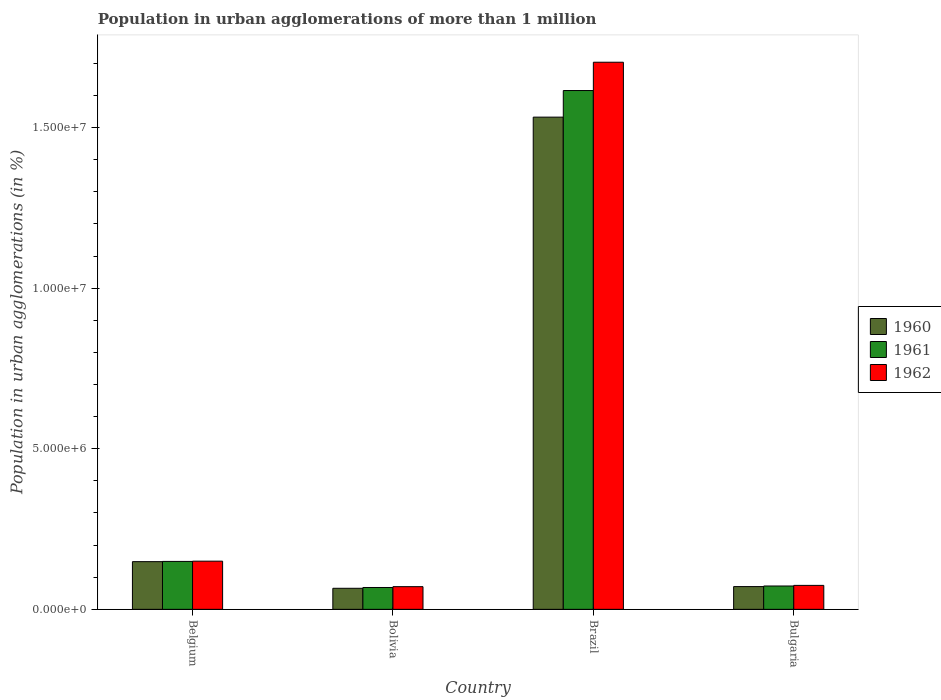How many groups of bars are there?
Your answer should be compact. 4. How many bars are there on the 1st tick from the right?
Provide a short and direct response. 3. In how many cases, is the number of bars for a given country not equal to the number of legend labels?
Offer a terse response. 0. What is the population in urban agglomerations in 1961 in Brazil?
Your answer should be compact. 1.62e+07. Across all countries, what is the maximum population in urban agglomerations in 1960?
Your answer should be very brief. 1.53e+07. Across all countries, what is the minimum population in urban agglomerations in 1960?
Your answer should be very brief. 6.55e+05. What is the total population in urban agglomerations in 1961 in the graph?
Your answer should be very brief. 1.91e+07. What is the difference between the population in urban agglomerations in 1960 in Belgium and that in Brazil?
Your answer should be very brief. -1.38e+07. What is the difference between the population in urban agglomerations in 1962 in Belgium and the population in urban agglomerations in 1961 in Bolivia?
Make the answer very short. 8.19e+05. What is the average population in urban agglomerations in 1962 per country?
Provide a succinct answer. 5.00e+06. What is the difference between the population in urban agglomerations of/in 1962 and population in urban agglomerations of/in 1961 in Brazil?
Give a very brief answer. 8.81e+05. In how many countries, is the population in urban agglomerations in 1960 greater than 1000000 %?
Provide a short and direct response. 2. What is the ratio of the population in urban agglomerations in 1961 in Belgium to that in Bolivia?
Give a very brief answer. 2.19. What is the difference between the highest and the second highest population in urban agglomerations in 1960?
Your answer should be compact. 7.77e+05. What is the difference between the highest and the lowest population in urban agglomerations in 1961?
Offer a terse response. 1.55e+07. In how many countries, is the population in urban agglomerations in 1962 greater than the average population in urban agglomerations in 1962 taken over all countries?
Your answer should be very brief. 1. Is the sum of the population in urban agglomerations in 1962 in Belgium and Brazil greater than the maximum population in urban agglomerations in 1960 across all countries?
Make the answer very short. Yes. What does the 3rd bar from the left in Brazil represents?
Keep it short and to the point. 1962. Is it the case that in every country, the sum of the population in urban agglomerations in 1960 and population in urban agglomerations in 1962 is greater than the population in urban agglomerations in 1961?
Offer a very short reply. Yes. Are all the bars in the graph horizontal?
Your response must be concise. No. Does the graph contain any zero values?
Offer a terse response. No. Where does the legend appear in the graph?
Your response must be concise. Center right. How many legend labels are there?
Your answer should be very brief. 3. How are the legend labels stacked?
Make the answer very short. Vertical. What is the title of the graph?
Your response must be concise. Population in urban agglomerations of more than 1 million. What is the label or title of the X-axis?
Provide a succinct answer. Country. What is the label or title of the Y-axis?
Make the answer very short. Population in urban agglomerations (in %). What is the Population in urban agglomerations (in %) of 1960 in Belgium?
Offer a very short reply. 1.48e+06. What is the Population in urban agglomerations (in %) of 1961 in Belgium?
Offer a very short reply. 1.49e+06. What is the Population in urban agglomerations (in %) of 1962 in Belgium?
Offer a terse response. 1.50e+06. What is the Population in urban agglomerations (in %) of 1960 in Bolivia?
Provide a succinct answer. 6.55e+05. What is the Population in urban agglomerations (in %) in 1961 in Bolivia?
Offer a very short reply. 6.80e+05. What is the Population in urban agglomerations (in %) in 1962 in Bolivia?
Provide a short and direct response. 7.06e+05. What is the Population in urban agglomerations (in %) of 1960 in Brazil?
Your answer should be very brief. 1.53e+07. What is the Population in urban agglomerations (in %) of 1961 in Brazil?
Provide a short and direct response. 1.62e+07. What is the Population in urban agglomerations (in %) of 1962 in Brazil?
Offer a very short reply. 1.70e+07. What is the Population in urban agglomerations (in %) in 1960 in Bulgaria?
Make the answer very short. 7.08e+05. What is the Population in urban agglomerations (in %) in 1961 in Bulgaria?
Offer a terse response. 7.27e+05. What is the Population in urban agglomerations (in %) of 1962 in Bulgaria?
Your answer should be compact. 7.46e+05. Across all countries, what is the maximum Population in urban agglomerations (in %) in 1960?
Your response must be concise. 1.53e+07. Across all countries, what is the maximum Population in urban agglomerations (in %) of 1961?
Offer a terse response. 1.62e+07. Across all countries, what is the maximum Population in urban agglomerations (in %) in 1962?
Provide a succinct answer. 1.70e+07. Across all countries, what is the minimum Population in urban agglomerations (in %) of 1960?
Provide a succinct answer. 6.55e+05. Across all countries, what is the minimum Population in urban agglomerations (in %) of 1961?
Your answer should be compact. 6.80e+05. Across all countries, what is the minimum Population in urban agglomerations (in %) of 1962?
Offer a terse response. 7.06e+05. What is the total Population in urban agglomerations (in %) in 1960 in the graph?
Your response must be concise. 1.82e+07. What is the total Population in urban agglomerations (in %) in 1961 in the graph?
Make the answer very short. 1.91e+07. What is the total Population in urban agglomerations (in %) in 1962 in the graph?
Make the answer very short. 2.00e+07. What is the difference between the Population in urban agglomerations (in %) of 1960 in Belgium and that in Bolivia?
Make the answer very short. 8.29e+05. What is the difference between the Population in urban agglomerations (in %) in 1961 in Belgium and that in Bolivia?
Make the answer very short. 8.12e+05. What is the difference between the Population in urban agglomerations (in %) of 1962 in Belgium and that in Bolivia?
Offer a very short reply. 7.94e+05. What is the difference between the Population in urban agglomerations (in %) in 1960 in Belgium and that in Brazil?
Provide a succinct answer. -1.38e+07. What is the difference between the Population in urban agglomerations (in %) of 1961 in Belgium and that in Brazil?
Offer a very short reply. -1.47e+07. What is the difference between the Population in urban agglomerations (in %) of 1962 in Belgium and that in Brazil?
Your response must be concise. -1.55e+07. What is the difference between the Population in urban agglomerations (in %) of 1960 in Belgium and that in Bulgaria?
Your answer should be compact. 7.77e+05. What is the difference between the Population in urban agglomerations (in %) in 1961 in Belgium and that in Bulgaria?
Provide a succinct answer. 7.65e+05. What is the difference between the Population in urban agglomerations (in %) of 1962 in Belgium and that in Bulgaria?
Offer a terse response. 7.54e+05. What is the difference between the Population in urban agglomerations (in %) in 1960 in Bolivia and that in Brazil?
Ensure brevity in your answer.  -1.47e+07. What is the difference between the Population in urban agglomerations (in %) of 1961 in Bolivia and that in Brazil?
Your answer should be very brief. -1.55e+07. What is the difference between the Population in urban agglomerations (in %) in 1962 in Bolivia and that in Brazil?
Ensure brevity in your answer.  -1.63e+07. What is the difference between the Population in urban agglomerations (in %) in 1960 in Bolivia and that in Bulgaria?
Make the answer very short. -5.27e+04. What is the difference between the Population in urban agglomerations (in %) of 1961 in Bolivia and that in Bulgaria?
Offer a very short reply. -4.64e+04. What is the difference between the Population in urban agglomerations (in %) in 1962 in Bolivia and that in Bulgaria?
Offer a terse response. -3.95e+04. What is the difference between the Population in urban agglomerations (in %) in 1960 in Brazil and that in Bulgaria?
Keep it short and to the point. 1.46e+07. What is the difference between the Population in urban agglomerations (in %) in 1961 in Brazil and that in Bulgaria?
Give a very brief answer. 1.54e+07. What is the difference between the Population in urban agglomerations (in %) of 1962 in Brazil and that in Bulgaria?
Provide a short and direct response. 1.63e+07. What is the difference between the Population in urban agglomerations (in %) in 1960 in Belgium and the Population in urban agglomerations (in %) in 1961 in Bolivia?
Ensure brevity in your answer.  8.05e+05. What is the difference between the Population in urban agglomerations (in %) of 1960 in Belgium and the Population in urban agglomerations (in %) of 1962 in Bolivia?
Offer a terse response. 7.79e+05. What is the difference between the Population in urban agglomerations (in %) in 1961 in Belgium and the Population in urban agglomerations (in %) in 1962 in Bolivia?
Your answer should be very brief. 7.86e+05. What is the difference between the Population in urban agglomerations (in %) of 1960 in Belgium and the Population in urban agglomerations (in %) of 1961 in Brazil?
Provide a succinct answer. -1.47e+07. What is the difference between the Population in urban agglomerations (in %) of 1960 in Belgium and the Population in urban agglomerations (in %) of 1962 in Brazil?
Your answer should be very brief. -1.55e+07. What is the difference between the Population in urban agglomerations (in %) of 1961 in Belgium and the Population in urban agglomerations (in %) of 1962 in Brazil?
Keep it short and to the point. -1.55e+07. What is the difference between the Population in urban agglomerations (in %) of 1960 in Belgium and the Population in urban agglomerations (in %) of 1961 in Bulgaria?
Your response must be concise. 7.58e+05. What is the difference between the Population in urban agglomerations (in %) in 1960 in Belgium and the Population in urban agglomerations (in %) in 1962 in Bulgaria?
Offer a terse response. 7.39e+05. What is the difference between the Population in urban agglomerations (in %) of 1961 in Belgium and the Population in urban agglomerations (in %) of 1962 in Bulgaria?
Make the answer very short. 7.46e+05. What is the difference between the Population in urban agglomerations (in %) in 1960 in Bolivia and the Population in urban agglomerations (in %) in 1961 in Brazil?
Your response must be concise. -1.55e+07. What is the difference between the Population in urban agglomerations (in %) in 1960 in Bolivia and the Population in urban agglomerations (in %) in 1962 in Brazil?
Keep it short and to the point. -1.64e+07. What is the difference between the Population in urban agglomerations (in %) of 1961 in Bolivia and the Population in urban agglomerations (in %) of 1962 in Brazil?
Offer a very short reply. -1.64e+07. What is the difference between the Population in urban agglomerations (in %) of 1960 in Bolivia and the Population in urban agglomerations (in %) of 1961 in Bulgaria?
Offer a terse response. -7.11e+04. What is the difference between the Population in urban agglomerations (in %) of 1960 in Bolivia and the Population in urban agglomerations (in %) of 1962 in Bulgaria?
Offer a terse response. -9.02e+04. What is the difference between the Population in urban agglomerations (in %) in 1961 in Bolivia and the Population in urban agglomerations (in %) in 1962 in Bulgaria?
Provide a short and direct response. -6.54e+04. What is the difference between the Population in urban agglomerations (in %) of 1960 in Brazil and the Population in urban agglomerations (in %) of 1961 in Bulgaria?
Offer a very short reply. 1.46e+07. What is the difference between the Population in urban agglomerations (in %) of 1960 in Brazil and the Population in urban agglomerations (in %) of 1962 in Bulgaria?
Provide a succinct answer. 1.46e+07. What is the difference between the Population in urban agglomerations (in %) in 1961 in Brazil and the Population in urban agglomerations (in %) in 1962 in Bulgaria?
Ensure brevity in your answer.  1.54e+07. What is the average Population in urban agglomerations (in %) of 1960 per country?
Give a very brief answer. 4.54e+06. What is the average Population in urban agglomerations (in %) of 1961 per country?
Offer a very short reply. 4.76e+06. What is the average Population in urban agglomerations (in %) in 1962 per country?
Your answer should be compact. 5.00e+06. What is the difference between the Population in urban agglomerations (in %) in 1960 and Population in urban agglomerations (in %) in 1961 in Belgium?
Offer a terse response. -7177. What is the difference between the Population in urban agglomerations (in %) of 1960 and Population in urban agglomerations (in %) of 1962 in Belgium?
Ensure brevity in your answer.  -1.49e+04. What is the difference between the Population in urban agglomerations (in %) in 1961 and Population in urban agglomerations (in %) in 1962 in Belgium?
Give a very brief answer. -7758. What is the difference between the Population in urban agglomerations (in %) of 1960 and Population in urban agglomerations (in %) of 1961 in Bolivia?
Keep it short and to the point. -2.48e+04. What is the difference between the Population in urban agglomerations (in %) of 1960 and Population in urban agglomerations (in %) of 1962 in Bolivia?
Offer a terse response. -5.06e+04. What is the difference between the Population in urban agglomerations (in %) in 1961 and Population in urban agglomerations (in %) in 1962 in Bolivia?
Your answer should be very brief. -2.58e+04. What is the difference between the Population in urban agglomerations (in %) of 1960 and Population in urban agglomerations (in %) of 1961 in Brazil?
Provide a succinct answer. -8.28e+05. What is the difference between the Population in urban agglomerations (in %) in 1960 and Population in urban agglomerations (in %) in 1962 in Brazil?
Your answer should be very brief. -1.71e+06. What is the difference between the Population in urban agglomerations (in %) of 1961 and Population in urban agglomerations (in %) of 1962 in Brazil?
Provide a succinct answer. -8.81e+05. What is the difference between the Population in urban agglomerations (in %) in 1960 and Population in urban agglomerations (in %) in 1961 in Bulgaria?
Ensure brevity in your answer.  -1.85e+04. What is the difference between the Population in urban agglomerations (in %) of 1960 and Population in urban agglomerations (in %) of 1962 in Bulgaria?
Offer a terse response. -3.75e+04. What is the difference between the Population in urban agglomerations (in %) in 1961 and Population in urban agglomerations (in %) in 1962 in Bulgaria?
Provide a short and direct response. -1.90e+04. What is the ratio of the Population in urban agglomerations (in %) in 1960 in Belgium to that in Bolivia?
Make the answer very short. 2.27. What is the ratio of the Population in urban agglomerations (in %) of 1961 in Belgium to that in Bolivia?
Ensure brevity in your answer.  2.19. What is the ratio of the Population in urban agglomerations (in %) in 1962 in Belgium to that in Bolivia?
Keep it short and to the point. 2.12. What is the ratio of the Population in urban agglomerations (in %) of 1960 in Belgium to that in Brazil?
Make the answer very short. 0.1. What is the ratio of the Population in urban agglomerations (in %) of 1961 in Belgium to that in Brazil?
Your answer should be compact. 0.09. What is the ratio of the Population in urban agglomerations (in %) in 1962 in Belgium to that in Brazil?
Keep it short and to the point. 0.09. What is the ratio of the Population in urban agglomerations (in %) in 1960 in Belgium to that in Bulgaria?
Provide a short and direct response. 2.1. What is the ratio of the Population in urban agglomerations (in %) of 1961 in Belgium to that in Bulgaria?
Offer a very short reply. 2.05. What is the ratio of the Population in urban agglomerations (in %) of 1962 in Belgium to that in Bulgaria?
Provide a short and direct response. 2.01. What is the ratio of the Population in urban agglomerations (in %) in 1960 in Bolivia to that in Brazil?
Offer a terse response. 0.04. What is the ratio of the Population in urban agglomerations (in %) of 1961 in Bolivia to that in Brazil?
Offer a very short reply. 0.04. What is the ratio of the Population in urban agglomerations (in %) of 1962 in Bolivia to that in Brazil?
Your answer should be compact. 0.04. What is the ratio of the Population in urban agglomerations (in %) of 1960 in Bolivia to that in Bulgaria?
Your answer should be very brief. 0.93. What is the ratio of the Population in urban agglomerations (in %) of 1961 in Bolivia to that in Bulgaria?
Ensure brevity in your answer.  0.94. What is the ratio of the Population in urban agglomerations (in %) in 1962 in Bolivia to that in Bulgaria?
Make the answer very short. 0.95. What is the ratio of the Population in urban agglomerations (in %) in 1960 in Brazil to that in Bulgaria?
Your answer should be compact. 21.64. What is the ratio of the Population in urban agglomerations (in %) in 1961 in Brazil to that in Bulgaria?
Your answer should be compact. 22.23. What is the ratio of the Population in urban agglomerations (in %) in 1962 in Brazil to that in Bulgaria?
Provide a short and direct response. 22.85. What is the difference between the highest and the second highest Population in urban agglomerations (in %) of 1960?
Your response must be concise. 1.38e+07. What is the difference between the highest and the second highest Population in urban agglomerations (in %) of 1961?
Keep it short and to the point. 1.47e+07. What is the difference between the highest and the second highest Population in urban agglomerations (in %) in 1962?
Offer a terse response. 1.55e+07. What is the difference between the highest and the lowest Population in urban agglomerations (in %) in 1960?
Make the answer very short. 1.47e+07. What is the difference between the highest and the lowest Population in urban agglomerations (in %) of 1961?
Your answer should be very brief. 1.55e+07. What is the difference between the highest and the lowest Population in urban agglomerations (in %) in 1962?
Ensure brevity in your answer.  1.63e+07. 